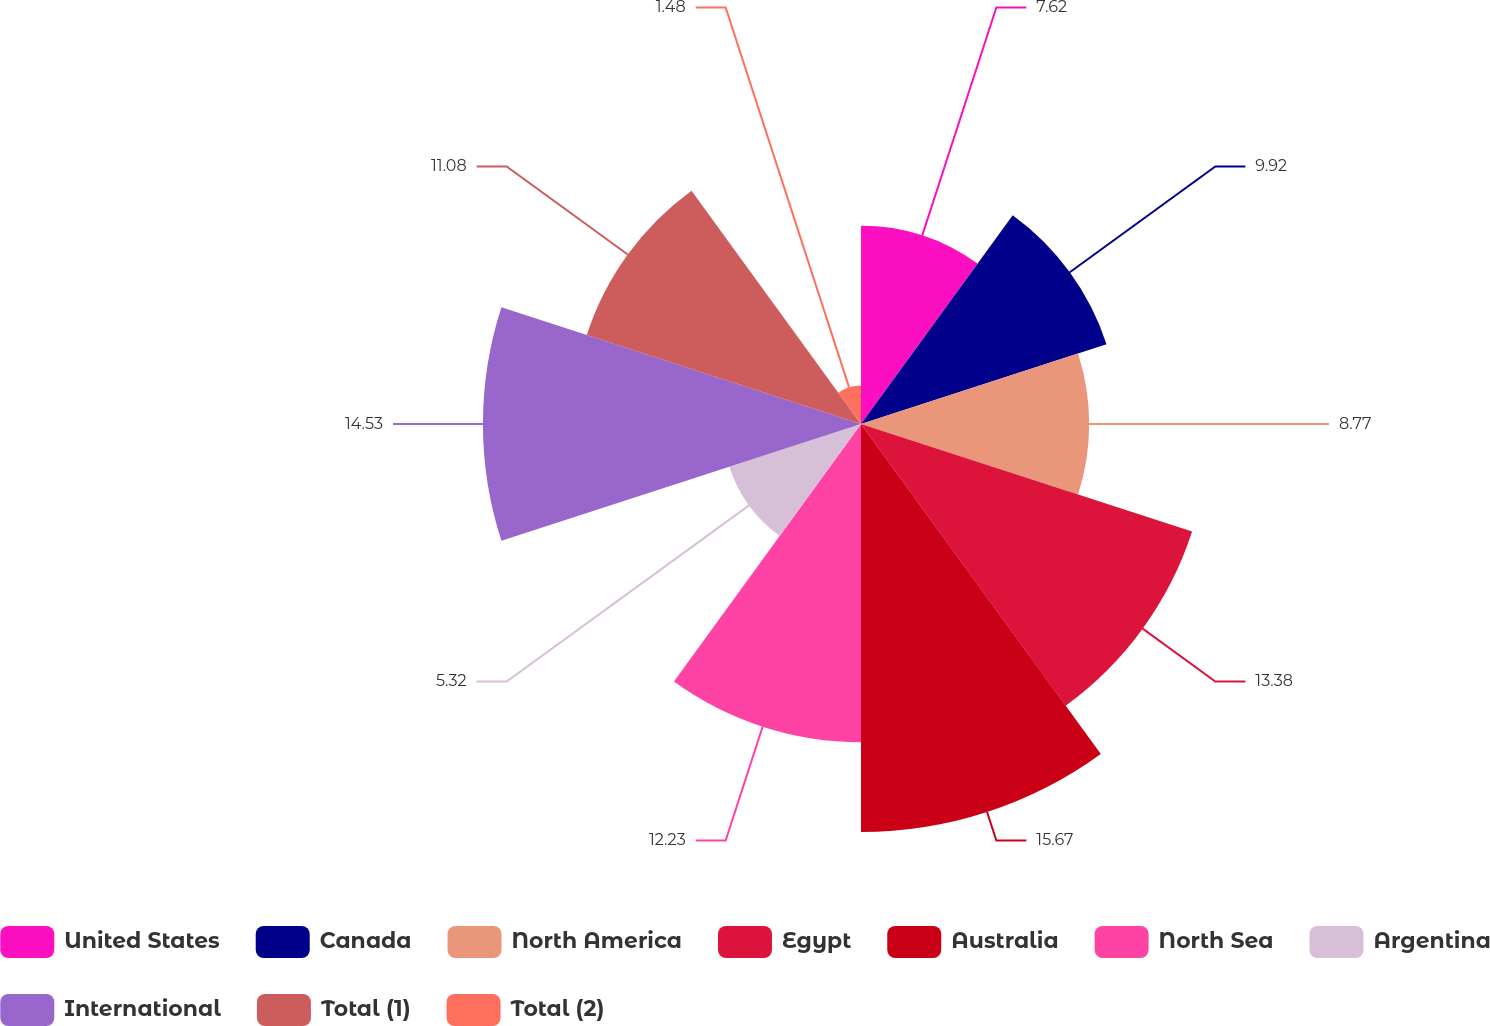<chart> <loc_0><loc_0><loc_500><loc_500><pie_chart><fcel>United States<fcel>Canada<fcel>North America<fcel>Egypt<fcel>Australia<fcel>North Sea<fcel>Argentina<fcel>International<fcel>Total (1)<fcel>Total (2)<nl><fcel>7.62%<fcel>9.92%<fcel>8.77%<fcel>13.38%<fcel>15.68%<fcel>12.23%<fcel>5.32%<fcel>14.53%<fcel>11.08%<fcel>1.48%<nl></chart> 